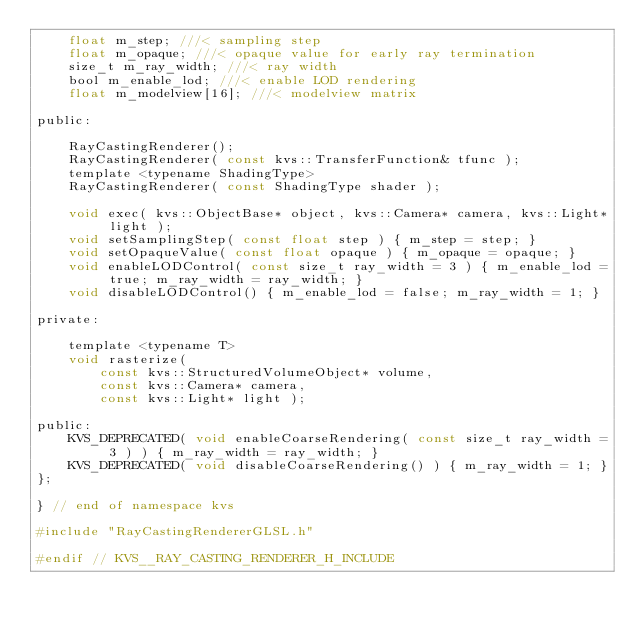Convert code to text. <code><loc_0><loc_0><loc_500><loc_500><_C_>    float m_step; ///< sampling step
    float m_opaque; ///< opaque value for early ray termination
    size_t m_ray_width; ///< ray width
    bool m_enable_lod; ///< enable LOD rendering
    float m_modelview[16]; ///< modelview matrix

public:

    RayCastingRenderer();
    RayCastingRenderer( const kvs::TransferFunction& tfunc );
    template <typename ShadingType>
    RayCastingRenderer( const ShadingType shader );

    void exec( kvs::ObjectBase* object, kvs::Camera* camera, kvs::Light* light );
    void setSamplingStep( const float step ) { m_step = step; }
    void setOpaqueValue( const float opaque ) { m_opaque = opaque; }
    void enableLODControl( const size_t ray_width = 3 ) { m_enable_lod = true; m_ray_width = ray_width; }
    void disableLODControl() { m_enable_lod = false; m_ray_width = 1; }

private:

    template <typename T>
    void rasterize(
        const kvs::StructuredVolumeObject* volume,
        const kvs::Camera* camera,
        const kvs::Light* light );

public:
    KVS_DEPRECATED( void enableCoarseRendering( const size_t ray_width = 3 ) ) { m_ray_width = ray_width; }
    KVS_DEPRECATED( void disableCoarseRendering() ) { m_ray_width = 1; }
};

} // end of namespace kvs

#include "RayCastingRendererGLSL.h"

#endif // KVS__RAY_CASTING_RENDERER_H_INCLUDE
</code> 